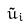<formula> <loc_0><loc_0><loc_500><loc_500>\tilde { u } _ { i }</formula> 